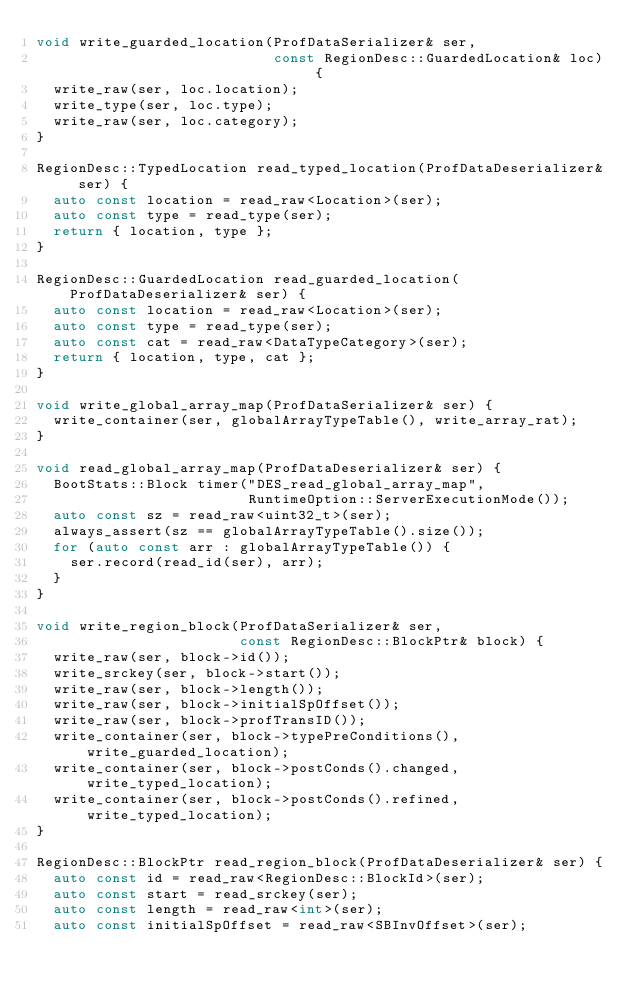Convert code to text. <code><loc_0><loc_0><loc_500><loc_500><_C++_>void write_guarded_location(ProfDataSerializer& ser,
                            const RegionDesc::GuardedLocation& loc) {
  write_raw(ser, loc.location);
  write_type(ser, loc.type);
  write_raw(ser, loc.category);
}

RegionDesc::TypedLocation read_typed_location(ProfDataDeserializer& ser) {
  auto const location = read_raw<Location>(ser);
  auto const type = read_type(ser);
  return { location, type };
}

RegionDesc::GuardedLocation read_guarded_location(ProfDataDeserializer& ser) {
  auto const location = read_raw<Location>(ser);
  auto const type = read_type(ser);
  auto const cat = read_raw<DataTypeCategory>(ser);
  return { location, type, cat };
}

void write_global_array_map(ProfDataSerializer& ser) {
  write_container(ser, globalArrayTypeTable(), write_array_rat);
}

void read_global_array_map(ProfDataDeserializer& ser) {
  BootStats::Block timer("DES_read_global_array_map",
                         RuntimeOption::ServerExecutionMode());
  auto const sz = read_raw<uint32_t>(ser);
  always_assert(sz == globalArrayTypeTable().size());
  for (auto const arr : globalArrayTypeTable()) {
    ser.record(read_id(ser), arr);
  }
}

void write_region_block(ProfDataSerializer& ser,
                        const RegionDesc::BlockPtr& block) {
  write_raw(ser, block->id());
  write_srckey(ser, block->start());
  write_raw(ser, block->length());
  write_raw(ser, block->initialSpOffset());
  write_raw(ser, block->profTransID());
  write_container(ser, block->typePreConditions(), write_guarded_location);
  write_container(ser, block->postConds().changed, write_typed_location);
  write_container(ser, block->postConds().refined, write_typed_location);
}

RegionDesc::BlockPtr read_region_block(ProfDataDeserializer& ser) {
  auto const id = read_raw<RegionDesc::BlockId>(ser);
  auto const start = read_srckey(ser);
  auto const length = read_raw<int>(ser);
  auto const initialSpOffset = read_raw<SBInvOffset>(ser);
</code> 